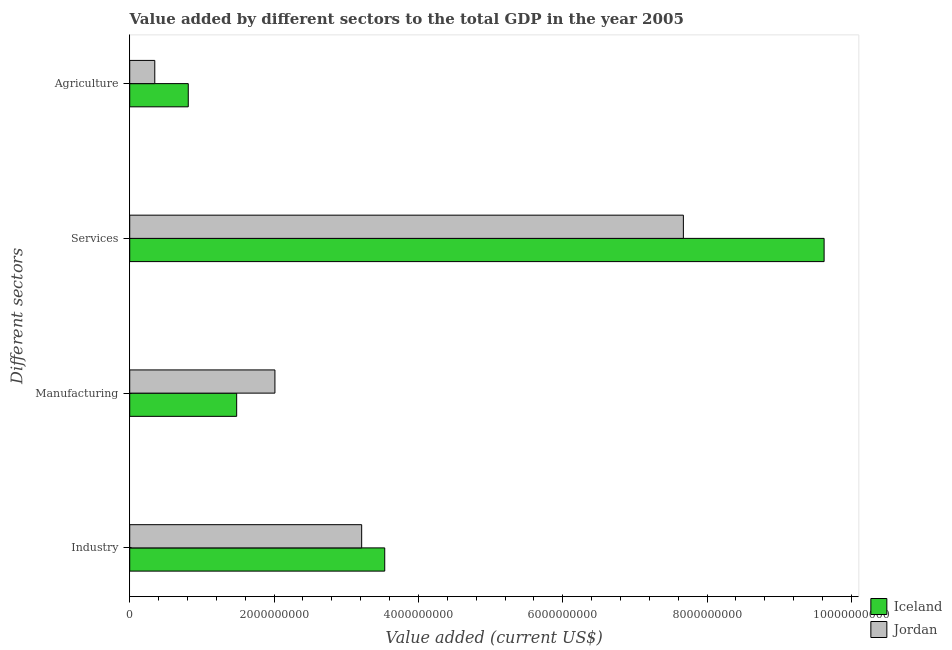How many groups of bars are there?
Ensure brevity in your answer.  4. Are the number of bars per tick equal to the number of legend labels?
Your answer should be very brief. Yes. Are the number of bars on each tick of the Y-axis equal?
Ensure brevity in your answer.  Yes. How many bars are there on the 4th tick from the top?
Your answer should be compact. 2. How many bars are there on the 3rd tick from the bottom?
Ensure brevity in your answer.  2. What is the label of the 2nd group of bars from the top?
Give a very brief answer. Services. What is the value added by agricultural sector in Iceland?
Ensure brevity in your answer.  8.11e+08. Across all countries, what is the maximum value added by manufacturing sector?
Ensure brevity in your answer.  2.01e+09. Across all countries, what is the minimum value added by agricultural sector?
Offer a very short reply. 3.47e+08. In which country was the value added by manufacturing sector maximum?
Make the answer very short. Jordan. In which country was the value added by manufacturing sector minimum?
Ensure brevity in your answer.  Iceland. What is the total value added by industrial sector in the graph?
Your response must be concise. 6.75e+09. What is the difference between the value added by manufacturing sector in Jordan and that in Iceland?
Provide a succinct answer. 5.30e+08. What is the difference between the value added by industrial sector in Jordan and the value added by manufacturing sector in Iceland?
Ensure brevity in your answer.  1.73e+09. What is the average value added by services sector per country?
Provide a succinct answer. 8.65e+09. What is the difference between the value added by industrial sector and value added by agricultural sector in Jordan?
Offer a very short reply. 2.87e+09. What is the ratio of the value added by industrial sector in Iceland to that in Jordan?
Provide a succinct answer. 1.1. Is the value added by manufacturing sector in Jordan less than that in Iceland?
Provide a succinct answer. No. What is the difference between the highest and the second highest value added by manufacturing sector?
Provide a succinct answer. 5.30e+08. What is the difference between the highest and the lowest value added by industrial sector?
Ensure brevity in your answer.  3.20e+08. Is it the case that in every country, the sum of the value added by manufacturing sector and value added by agricultural sector is greater than the sum of value added by services sector and value added by industrial sector?
Provide a succinct answer. No. Is it the case that in every country, the sum of the value added by industrial sector and value added by manufacturing sector is greater than the value added by services sector?
Your answer should be compact. No. Are all the bars in the graph horizontal?
Provide a short and direct response. Yes. Does the graph contain any zero values?
Provide a succinct answer. No. Does the graph contain grids?
Your response must be concise. No. Where does the legend appear in the graph?
Your response must be concise. Bottom right. How are the legend labels stacked?
Give a very brief answer. Vertical. What is the title of the graph?
Offer a terse response. Value added by different sectors to the total GDP in the year 2005. Does "Romania" appear as one of the legend labels in the graph?
Offer a very short reply. No. What is the label or title of the X-axis?
Offer a terse response. Value added (current US$). What is the label or title of the Y-axis?
Your response must be concise. Different sectors. What is the Value added (current US$) of Iceland in Industry?
Provide a succinct answer. 3.53e+09. What is the Value added (current US$) in Jordan in Industry?
Your answer should be compact. 3.21e+09. What is the Value added (current US$) of Iceland in Manufacturing?
Offer a terse response. 1.48e+09. What is the Value added (current US$) of Jordan in Manufacturing?
Keep it short and to the point. 2.01e+09. What is the Value added (current US$) of Iceland in Services?
Provide a succinct answer. 9.62e+09. What is the Value added (current US$) of Jordan in Services?
Provide a short and direct response. 7.67e+09. What is the Value added (current US$) in Iceland in Agriculture?
Your response must be concise. 8.11e+08. What is the Value added (current US$) in Jordan in Agriculture?
Make the answer very short. 3.47e+08. Across all Different sectors, what is the maximum Value added (current US$) in Iceland?
Offer a terse response. 9.62e+09. Across all Different sectors, what is the maximum Value added (current US$) in Jordan?
Your response must be concise. 7.67e+09. Across all Different sectors, what is the minimum Value added (current US$) of Iceland?
Make the answer very short. 8.11e+08. Across all Different sectors, what is the minimum Value added (current US$) of Jordan?
Your answer should be compact. 3.47e+08. What is the total Value added (current US$) in Iceland in the graph?
Offer a terse response. 1.54e+1. What is the total Value added (current US$) in Jordan in the graph?
Give a very brief answer. 1.32e+1. What is the difference between the Value added (current US$) in Iceland in Industry and that in Manufacturing?
Offer a very short reply. 2.05e+09. What is the difference between the Value added (current US$) in Jordan in Industry and that in Manufacturing?
Your answer should be very brief. 1.20e+09. What is the difference between the Value added (current US$) of Iceland in Industry and that in Services?
Offer a terse response. -6.09e+09. What is the difference between the Value added (current US$) in Jordan in Industry and that in Services?
Keep it short and to the point. -4.46e+09. What is the difference between the Value added (current US$) in Iceland in Industry and that in Agriculture?
Your response must be concise. 2.72e+09. What is the difference between the Value added (current US$) of Jordan in Industry and that in Agriculture?
Your answer should be very brief. 2.87e+09. What is the difference between the Value added (current US$) of Iceland in Manufacturing and that in Services?
Provide a short and direct response. -8.14e+09. What is the difference between the Value added (current US$) of Jordan in Manufacturing and that in Services?
Provide a succinct answer. -5.66e+09. What is the difference between the Value added (current US$) in Iceland in Manufacturing and that in Agriculture?
Make the answer very short. 6.71e+08. What is the difference between the Value added (current US$) in Jordan in Manufacturing and that in Agriculture?
Your response must be concise. 1.66e+09. What is the difference between the Value added (current US$) of Iceland in Services and that in Agriculture?
Ensure brevity in your answer.  8.81e+09. What is the difference between the Value added (current US$) of Jordan in Services and that in Agriculture?
Your answer should be compact. 7.32e+09. What is the difference between the Value added (current US$) of Iceland in Industry and the Value added (current US$) of Jordan in Manufacturing?
Ensure brevity in your answer.  1.52e+09. What is the difference between the Value added (current US$) of Iceland in Industry and the Value added (current US$) of Jordan in Services?
Provide a short and direct response. -4.14e+09. What is the difference between the Value added (current US$) in Iceland in Industry and the Value added (current US$) in Jordan in Agriculture?
Provide a short and direct response. 3.19e+09. What is the difference between the Value added (current US$) in Iceland in Manufacturing and the Value added (current US$) in Jordan in Services?
Keep it short and to the point. -6.19e+09. What is the difference between the Value added (current US$) of Iceland in Manufacturing and the Value added (current US$) of Jordan in Agriculture?
Keep it short and to the point. 1.13e+09. What is the difference between the Value added (current US$) of Iceland in Services and the Value added (current US$) of Jordan in Agriculture?
Your answer should be very brief. 9.27e+09. What is the average Value added (current US$) in Iceland per Different sectors?
Your response must be concise. 3.86e+09. What is the average Value added (current US$) in Jordan per Different sectors?
Provide a short and direct response. 3.31e+09. What is the difference between the Value added (current US$) of Iceland and Value added (current US$) of Jordan in Industry?
Offer a terse response. 3.20e+08. What is the difference between the Value added (current US$) in Iceland and Value added (current US$) in Jordan in Manufacturing?
Offer a very short reply. -5.30e+08. What is the difference between the Value added (current US$) in Iceland and Value added (current US$) in Jordan in Services?
Ensure brevity in your answer.  1.95e+09. What is the difference between the Value added (current US$) in Iceland and Value added (current US$) in Jordan in Agriculture?
Provide a succinct answer. 4.64e+08. What is the ratio of the Value added (current US$) of Iceland in Industry to that in Manufacturing?
Keep it short and to the point. 2.38. What is the ratio of the Value added (current US$) of Jordan in Industry to that in Manufacturing?
Make the answer very short. 1.6. What is the ratio of the Value added (current US$) of Iceland in Industry to that in Services?
Make the answer very short. 0.37. What is the ratio of the Value added (current US$) in Jordan in Industry to that in Services?
Your response must be concise. 0.42. What is the ratio of the Value added (current US$) of Iceland in Industry to that in Agriculture?
Provide a succinct answer. 4.36. What is the ratio of the Value added (current US$) in Jordan in Industry to that in Agriculture?
Make the answer very short. 9.25. What is the ratio of the Value added (current US$) of Iceland in Manufacturing to that in Services?
Make the answer very short. 0.15. What is the ratio of the Value added (current US$) of Jordan in Manufacturing to that in Services?
Provide a succinct answer. 0.26. What is the ratio of the Value added (current US$) of Iceland in Manufacturing to that in Agriculture?
Offer a terse response. 1.83. What is the ratio of the Value added (current US$) of Jordan in Manufacturing to that in Agriculture?
Offer a very short reply. 5.79. What is the ratio of the Value added (current US$) of Iceland in Services to that in Agriculture?
Give a very brief answer. 11.86. What is the ratio of the Value added (current US$) in Jordan in Services to that in Agriculture?
Your answer should be compact. 22.09. What is the difference between the highest and the second highest Value added (current US$) in Iceland?
Your answer should be compact. 6.09e+09. What is the difference between the highest and the second highest Value added (current US$) of Jordan?
Offer a very short reply. 4.46e+09. What is the difference between the highest and the lowest Value added (current US$) of Iceland?
Make the answer very short. 8.81e+09. What is the difference between the highest and the lowest Value added (current US$) of Jordan?
Your response must be concise. 7.32e+09. 